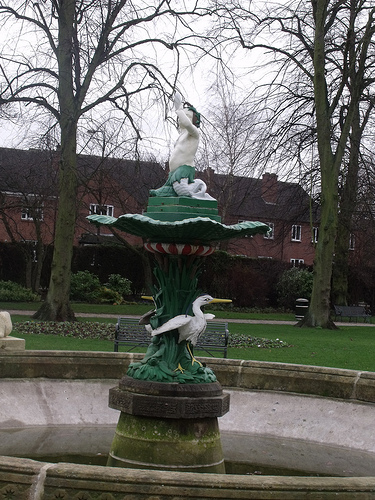<image>
Is there a bench above the fountain? No. The bench is not positioned above the fountain. The vertical arrangement shows a different relationship. 